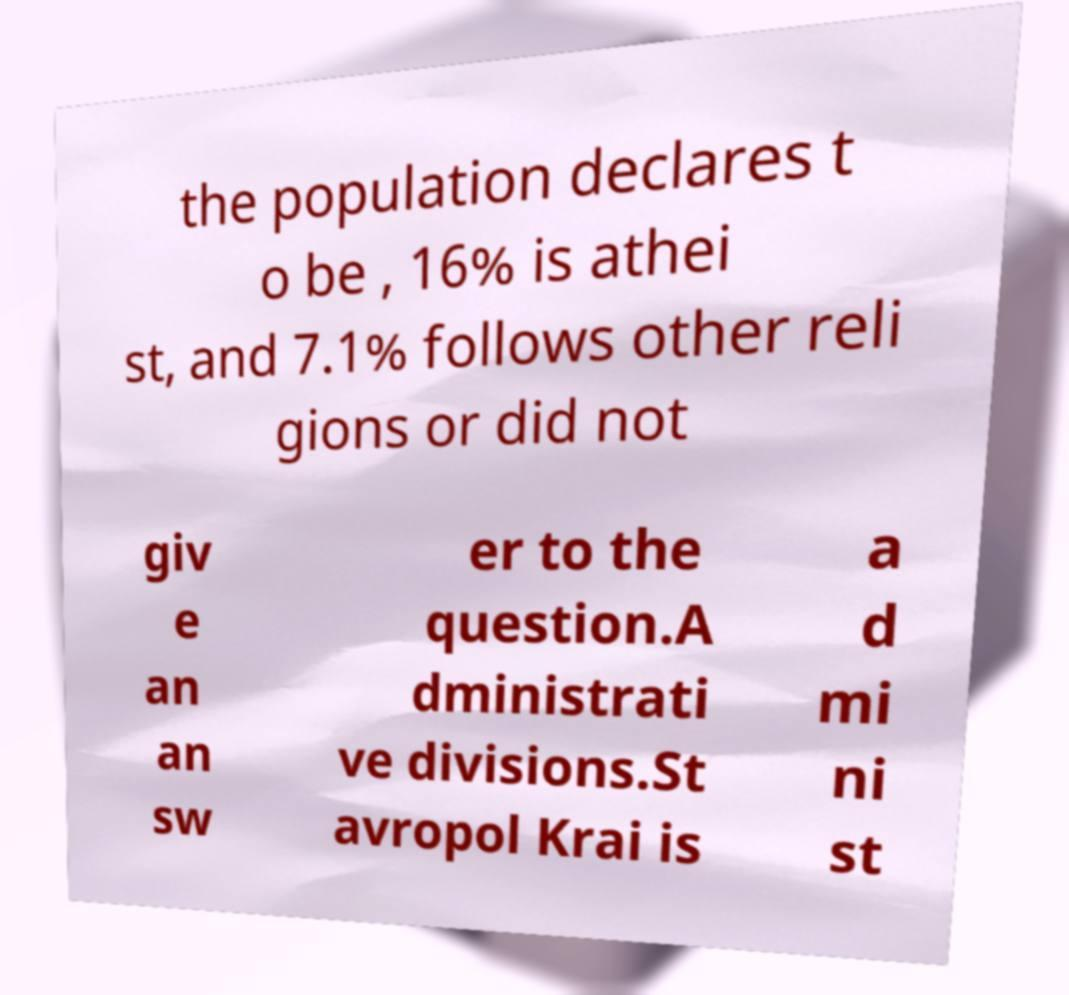Can you accurately transcribe the text from the provided image for me? the population declares t o be , 16% is athei st, and 7.1% follows other reli gions or did not giv e an an sw er to the question.A dministrati ve divisions.St avropol Krai is a d mi ni st 